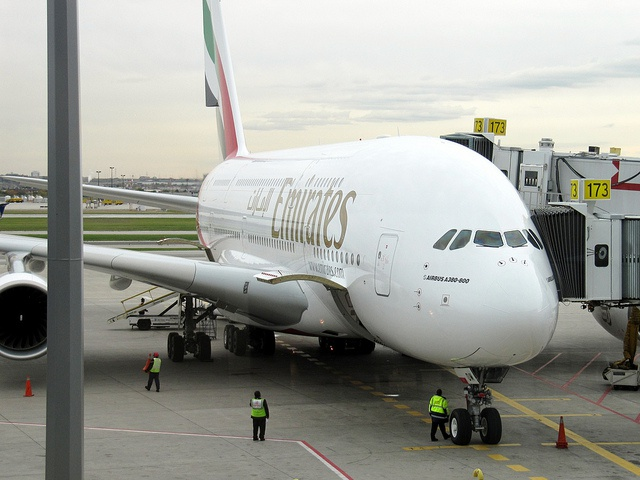Describe the objects in this image and their specific colors. I can see airplane in lightgray, darkgray, gray, and black tones, people in white, black, olive, lime, and darkgreen tones, people in white, black, gray, green, and darkgray tones, and people in white, black, olive, darkgreen, and gray tones in this image. 